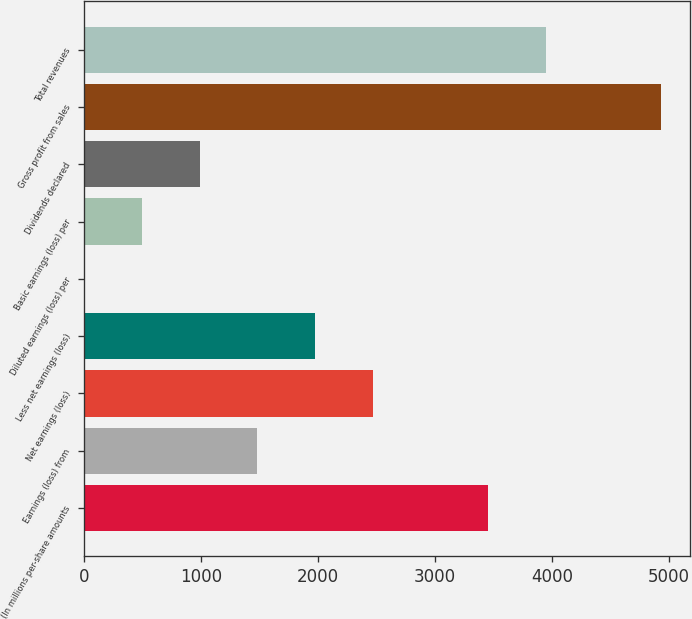Convert chart. <chart><loc_0><loc_0><loc_500><loc_500><bar_chart><fcel>(In millions per-share amounts<fcel>Earnings (loss) from<fcel>Net earnings (loss)<fcel>Less net earnings (loss)<fcel>Diluted earnings (loss) per<fcel>Basic earnings (loss) per<fcel>Dividends declared<fcel>Gross profit from sales<fcel>Total revenues<nl><fcel>3455.21<fcel>1480.81<fcel>2468.01<fcel>1974.41<fcel>0.01<fcel>493.61<fcel>987.21<fcel>4936<fcel>3948.81<nl></chart> 